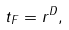Convert formula to latex. <formula><loc_0><loc_0><loc_500><loc_500>t _ { F } = r ^ { D } ,</formula> 